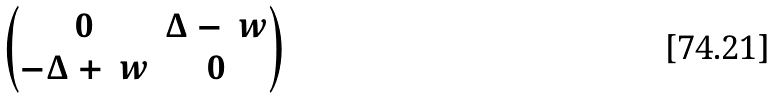<formula> <loc_0><loc_0><loc_500><loc_500>\begin{pmatrix} 0 & \Delta - \ w \\ - \Delta + \ w & 0 \end{pmatrix}</formula> 